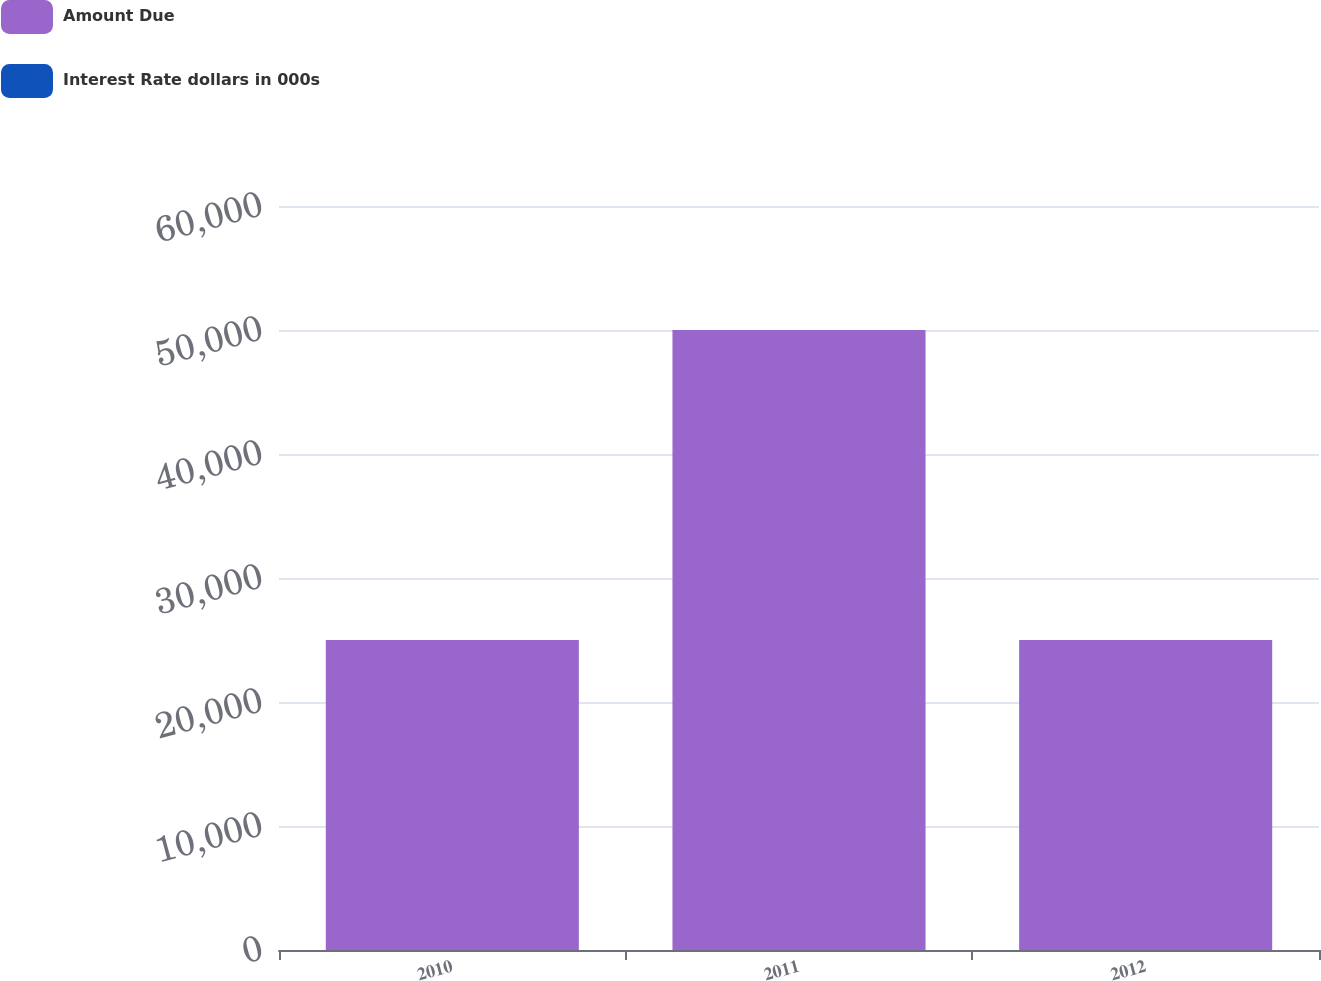Convert chart. <chart><loc_0><loc_0><loc_500><loc_500><stacked_bar_chart><ecel><fcel>2010<fcel>2011<fcel>2012<nl><fcel>Amount Due<fcel>25000<fcel>50000<fcel>25000<nl><fcel>Interest Rate dollars in 000s<fcel>1.76<fcel>1.92<fcel>2.36<nl></chart> 